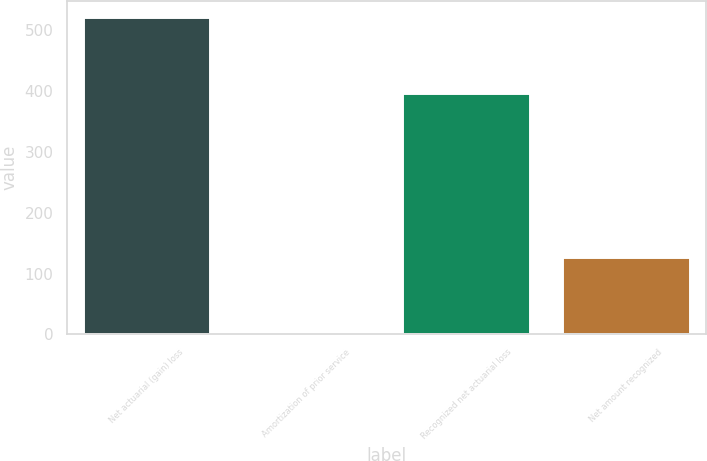Convert chart to OTSL. <chart><loc_0><loc_0><loc_500><loc_500><bar_chart><fcel>Net actuarial (gain) loss<fcel>Amortization of prior service<fcel>Recognized net actuarial loss<fcel>Net amount recognized<nl><fcel>521.4<fcel>3<fcel>396.9<fcel>126.8<nl></chart> 